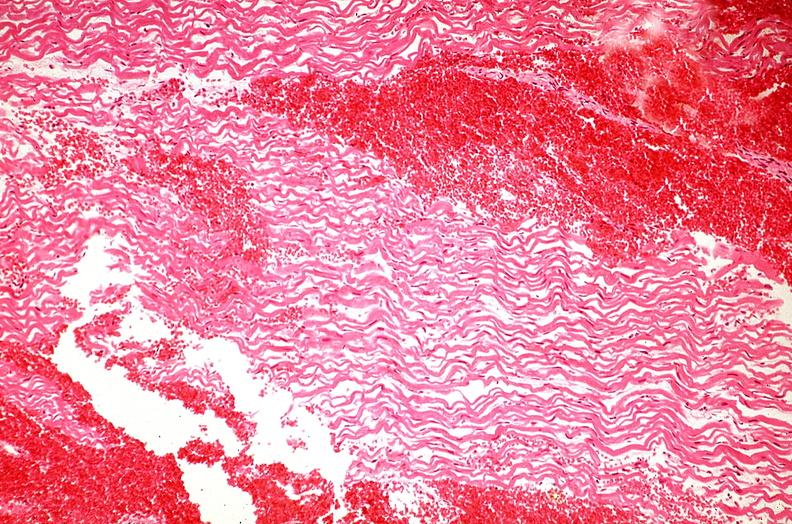s cardiovascular present?
Answer the question using a single word or phrase. Yes 